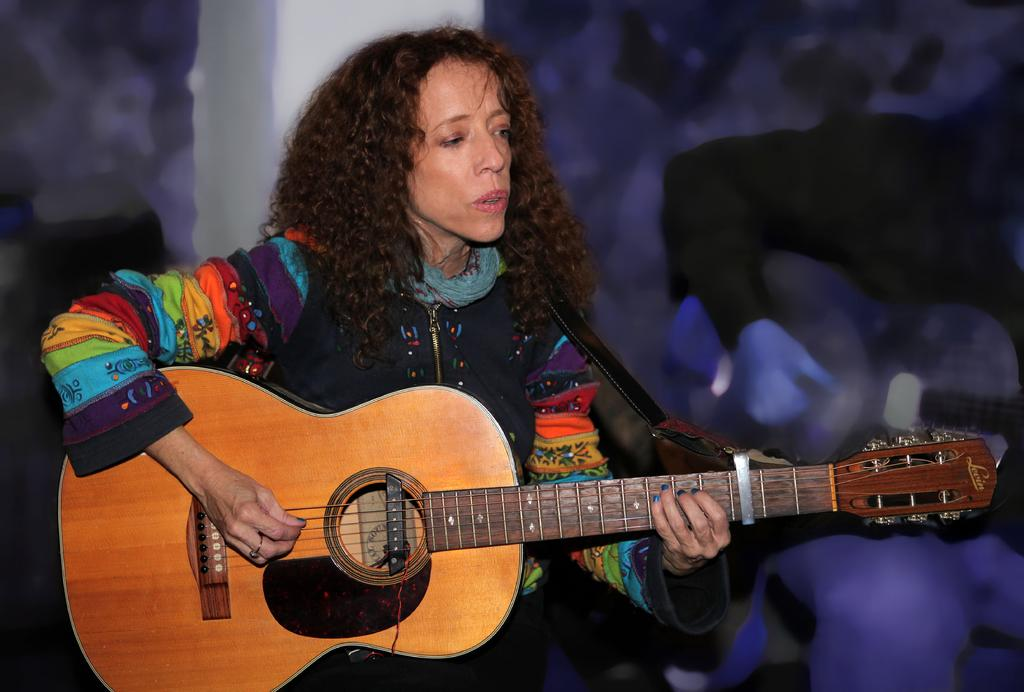Who is the main subject in the image? There is a woman in the image. Can you describe the woman's hair? The woman has curly hair. What is the woman doing in the image? The woman is sitting and playing a guitar. What type of game is the woman playing in the image? There is no game present in the image; the woman is playing a guitar. Can you tell me when the woman's birthday is in the image? There is no information about the woman's birthday in the image. 